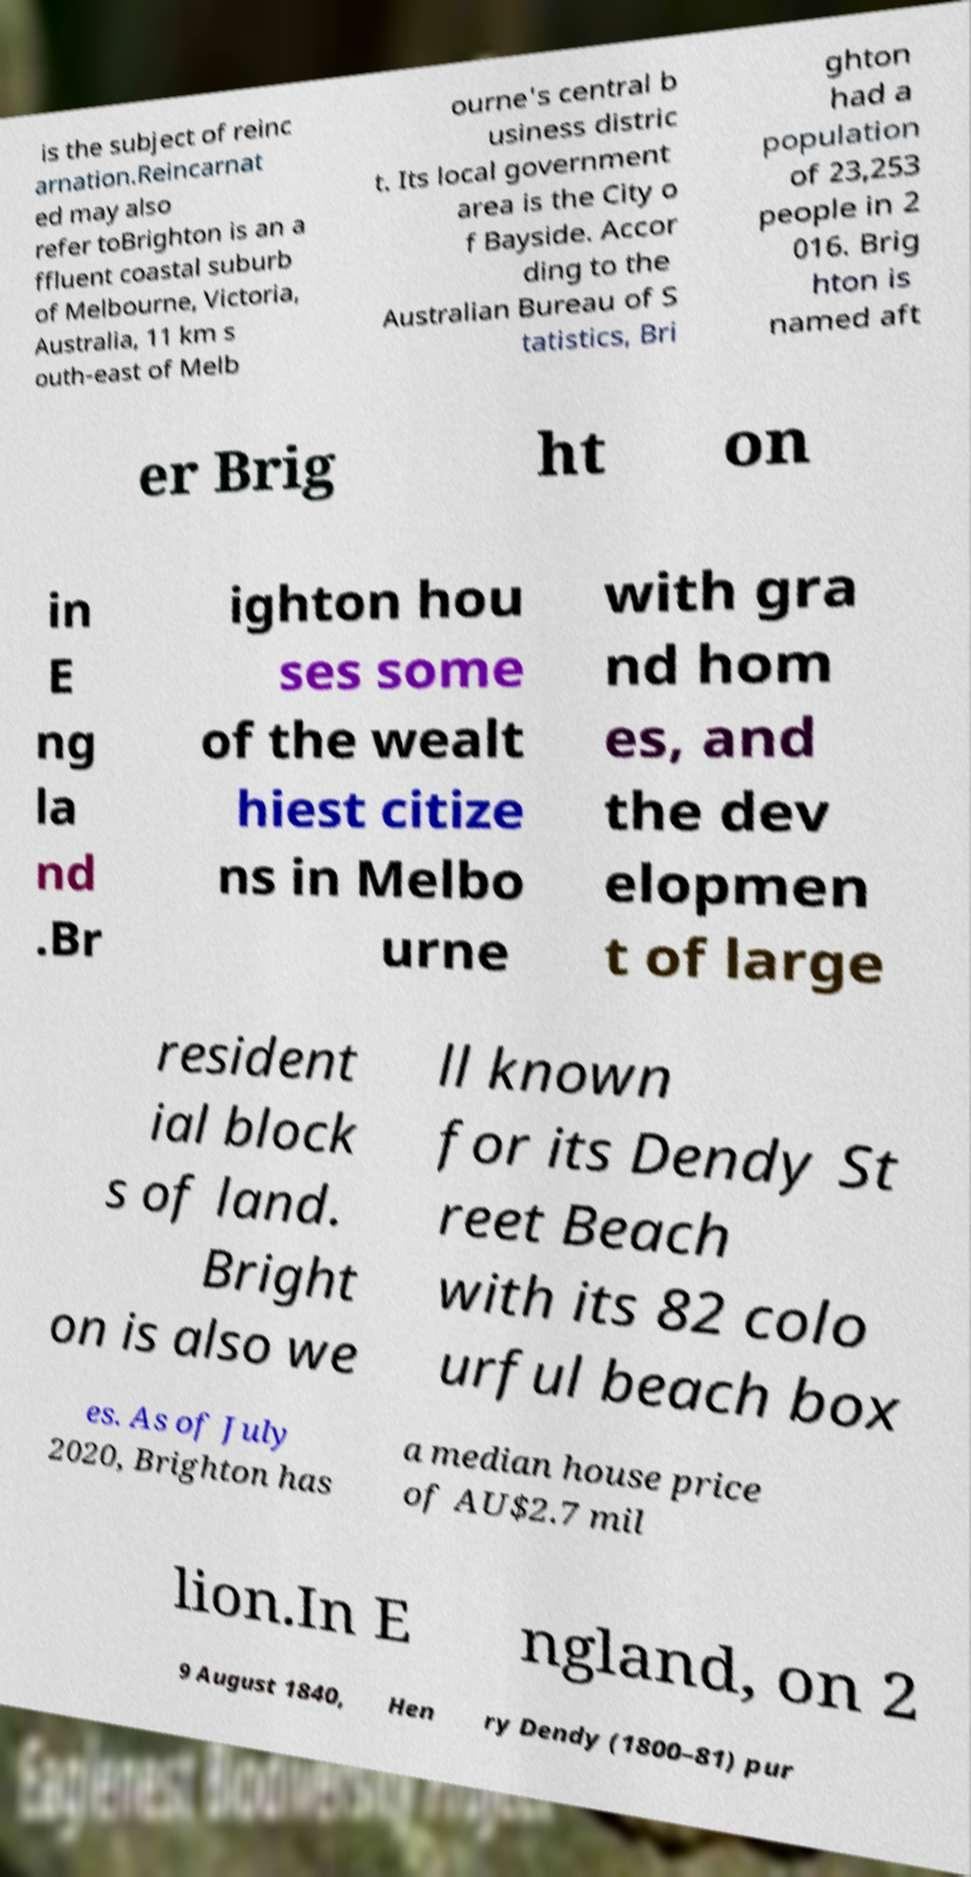Could you assist in decoding the text presented in this image and type it out clearly? is the subject of reinc arnation.Reincarnat ed may also refer toBrighton is an a ffluent coastal suburb of Melbourne, Victoria, Australia, 11 km s outh-east of Melb ourne's central b usiness distric t. Its local government area is the City o f Bayside. Accor ding to the Australian Bureau of S tatistics, Bri ghton had a population of 23,253 people in 2 016. Brig hton is named aft er Brig ht on in E ng la nd .Br ighton hou ses some of the wealt hiest citize ns in Melbo urne with gra nd hom es, and the dev elopmen t of large resident ial block s of land. Bright on is also we ll known for its Dendy St reet Beach with its 82 colo urful beach box es. As of July 2020, Brighton has a median house price of AU$2.7 mil lion.In E ngland, on 2 9 August 1840, Hen ry Dendy (1800–81) pur 